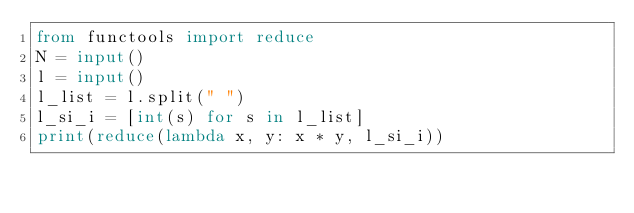<code> <loc_0><loc_0><loc_500><loc_500><_Python_>from functools import reduce
N = input()
l = input()
l_list = l.split(" ")
l_si_i = [int(s) for s in l_list]
print(reduce(lambda x, y: x * y, l_si_i))</code> 